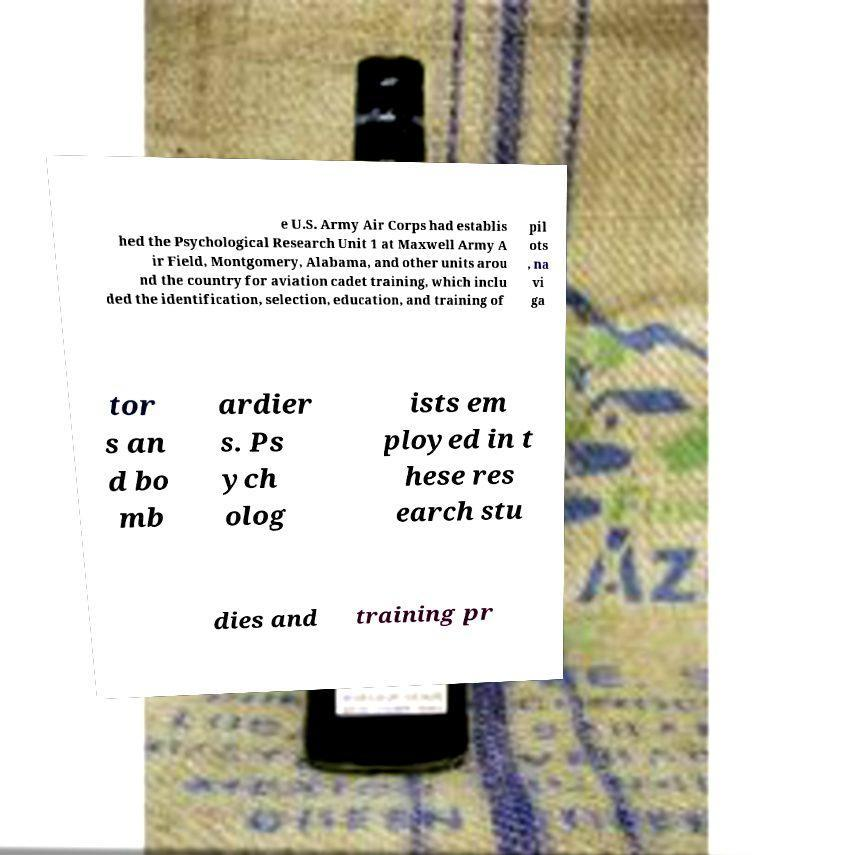Please read and relay the text visible in this image. What does it say? e U.S. Army Air Corps had establis hed the Psychological Research Unit 1 at Maxwell Army A ir Field, Montgomery, Alabama, and other units arou nd the country for aviation cadet training, which inclu ded the identification, selection, education, and training of pil ots , na vi ga tor s an d bo mb ardier s. Ps ych olog ists em ployed in t hese res earch stu dies and training pr 